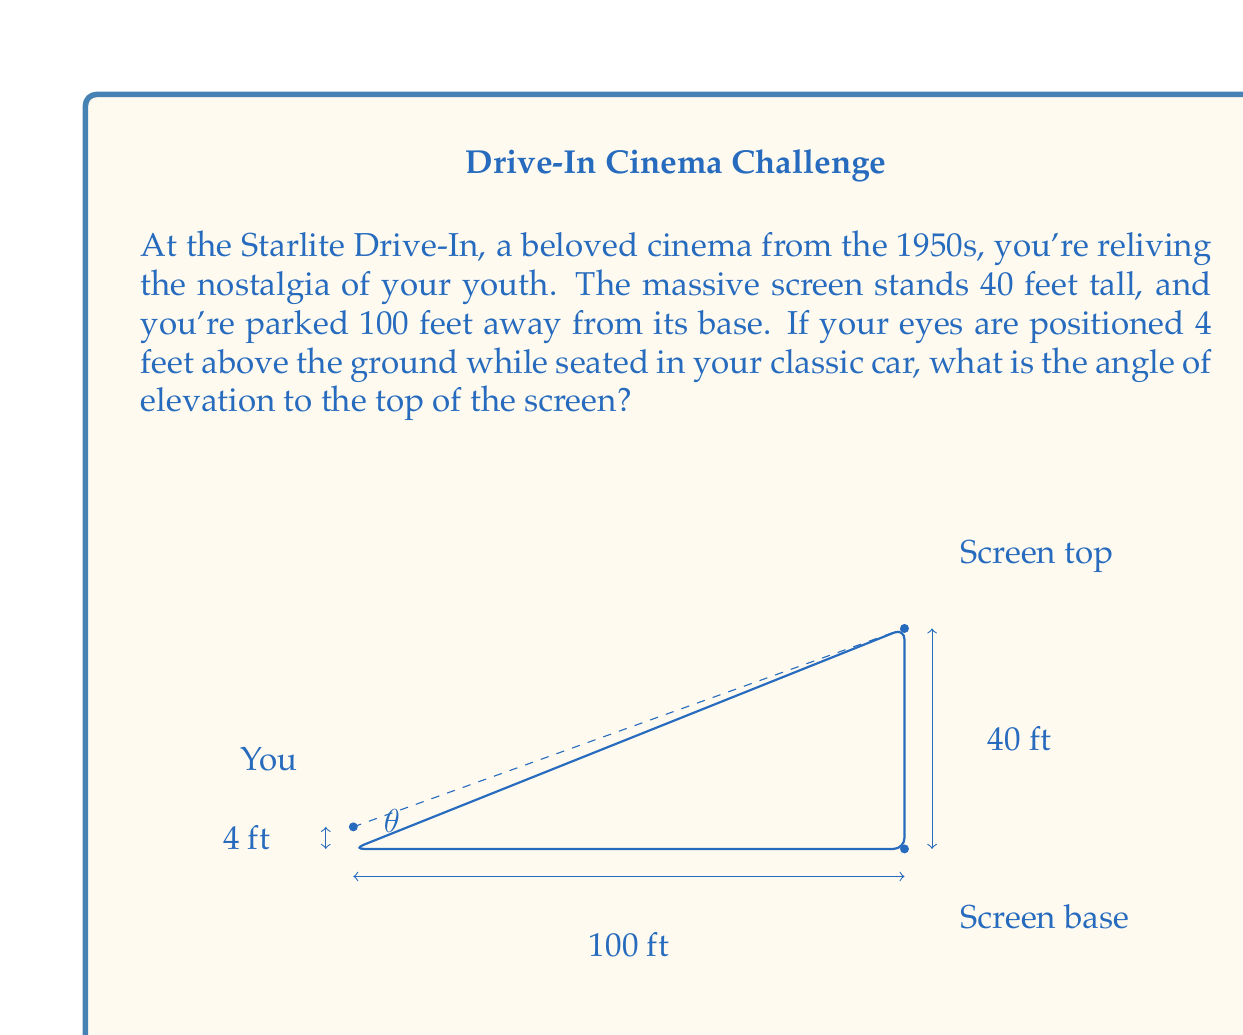Give your solution to this math problem. To solve this problem, we'll use trigonometry, specifically the tangent function. Let's break it down step-by-step:

1) First, we need to identify the right triangle formed by your line of sight to the top of the screen. The angle we're looking for is at the base of this triangle, where you're seated.

2) In this right triangle:
   - The adjacent side is the horizontal distance from you to the screen: 100 feet
   - The opposite side is the height difference between your eye level and the top of the screen

3) To find the opposite side:
   Height of screen: 40 feet
   Your eye level: 4 feet
   Difference: 40 - 4 = 36 feet

4) Now we can use the tangent function:

   $$\tan(\theta) = \frac{\text{opposite}}{\text{adjacent}} = \frac{36}{100}$$

5) To find $\theta$, we need to use the inverse tangent (arctangent) function:

   $$\theta = \tan^{-1}\left(\frac{36}{100}\right)$$

6) Using a calculator or computer:

   $$\theta \approx 19.80\text{ degrees}$$

This angle represents the elevation from your horizontal line of sight to the top of the screen.
Answer: The angle of elevation to the top of the drive-in movie screen is approximately $19.80\text{ degrees}$. 